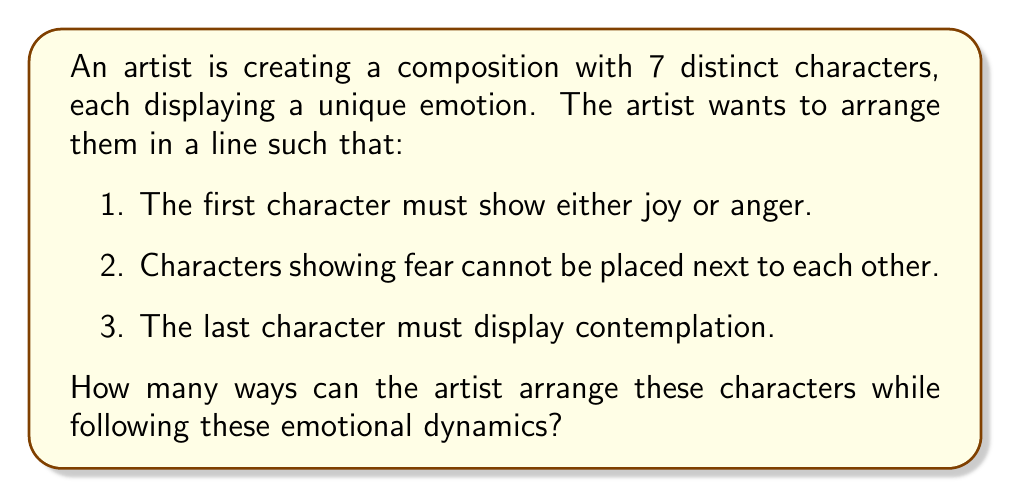Give your solution to this math problem. Let's approach this step-by-step:

1) First, we need to determine how many ways we can choose the emotions for each character:
   - We have 2 choices for the first character (joy or anger)
   - We have 1 fixed choice for the last character (contemplation)
   - We have 5 characters left to assign 5 emotions from the remaining 6 emotions

2) Let's count the number of ways to assign emotions to the middle 5 characters:
   $$\binom{6}{5} = 6$$

3) Now, for each emotion assignment, we need to count the valid arrangements:
   - We have 5! ways to arrange the middle 5 characters
   - However, we need to subtract arrangements where characters showing fear are adjacent

4) To count arrangements with adjacent fear:
   - Choose 2 fear characters: $\binom{5}{2} = 10$
   - Treat these 2 as one unit, so we now have 4 units to arrange: 4! = 24
   - Total arrangements with adjacent fear: $10 \times 24 = 240$

5) Therefore, valid arrangements for each emotion assignment:
   $$5! - 240 = 120 - 240 = 120$$

6) Putting it all together:
   $$2 \times 6 \times 120 = 1440$$

Thus, there are 1440 ways to arrange the characters following the given emotional dynamics.
Answer: 1440 